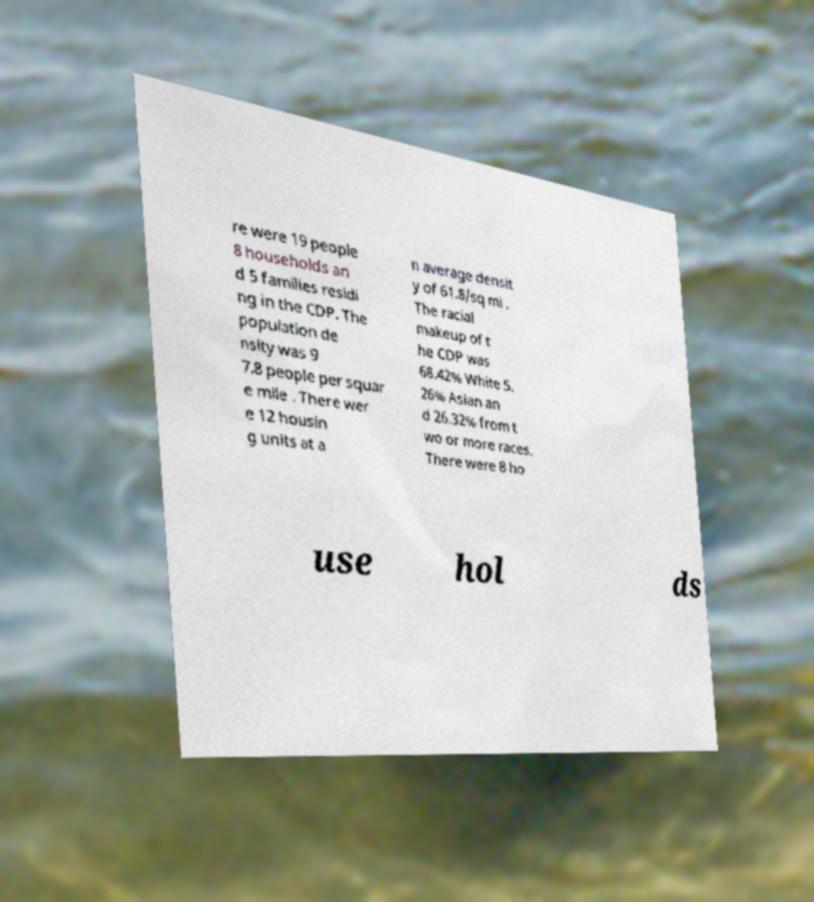Can you read and provide the text displayed in the image?This photo seems to have some interesting text. Can you extract and type it out for me? re were 19 people 8 households an d 5 families residi ng in the CDP. The population de nsity was 9 7.8 people per squar e mile . There wer e 12 housin g units at a n average densit y of 61.8/sq mi . The racial makeup of t he CDP was 68.42% White 5. 26% Asian an d 26.32% from t wo or more races. There were 8 ho use hol ds 